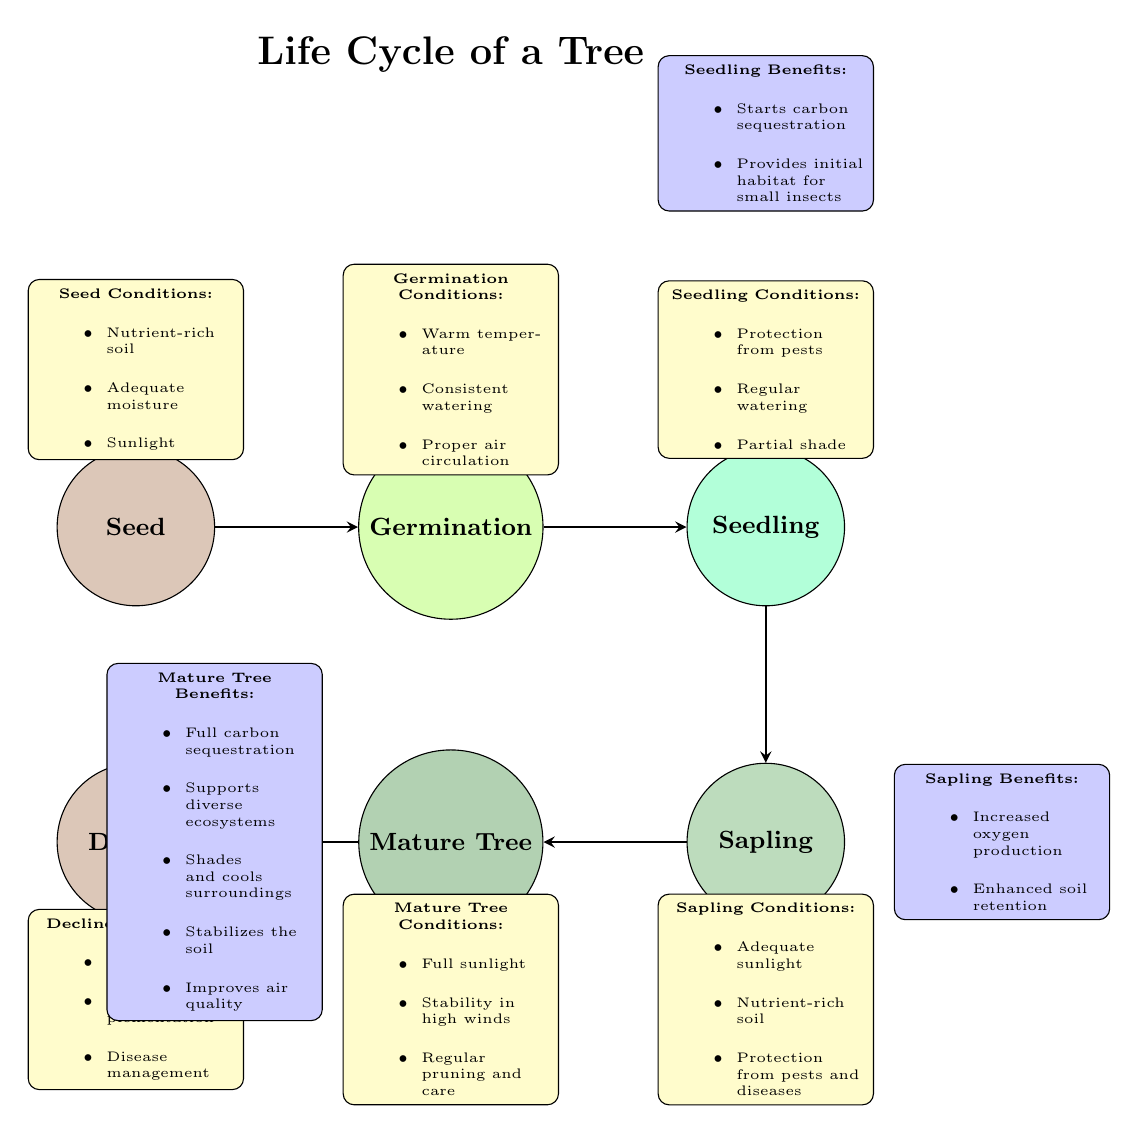What is the first stage in the life cycle of a tree? The diagram indicates that the first stage is labeled as "Seed." This can be observed at the leftmost position in the diagram.
Answer: Seed How many stages are there in the life cycle of a tree? The diagram shows a total of six distinct stages: Seed, Germination, Seedling, Sapling, Mature Tree, and Decline. By counting the nodes representing these stages, it confirms there are six.
Answer: 6 What color represents the Germination stage? The diagram uses a specific RGB color code for each stage. The Germination stage is filled with a color defined by RGB values resulting in a light green shade.
Answer: Light green What is one condition required for the Seedlings' growth? Under the Seedling Conditions section, it is stated that one requirement is "Protection from pests." This highlights a critical aspect of growing seedlings effectively.
Answer: Protection from pests Which stage benefits from increased oxygen production? The diagram indicates that the "Sapling" stage benefits from increased oxygen production. This is positioned next to the explanation for the benefits of a sapling.
Answer: Sapling What is the primary benefit of a Mature Tree? The diagram outlines several benefits, but one notable primary benefit of a Mature Tree is "Full carbon sequestration," emphasizing its ecological value.
Answer: Full carbon sequestration What is the relationship between the Sapling and Mature Tree stages? In the diagram, the Sapling stage leads directly to the Mature Tree stage, indicating a progression in the life cycle. This is represented by an arrow connecting the two stages.
Answer: Sapling leads to Mature Tree What condition is emphasized for a Mature Tree? The diagram specifies that a Mature Tree requires "Full sunlight" among other conditions for optimal growth. This is directly stated under its respective conditions section.
Answer: Full sunlight What two conditions are noted for the Decline stage? Two conditions that need to be managed for the Decline stage, as per the diagram, are "Pest control" and "Nutrient supplementation." Both are stated under the Decline Conditions.
Answer: Pest control and Nutrient supplementation 